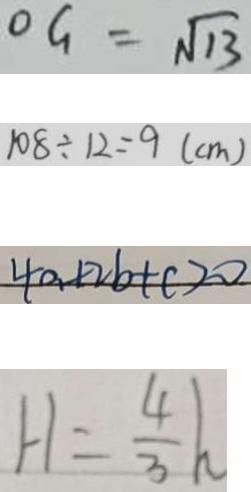<formula> <loc_0><loc_0><loc_500><loc_500>O G = \sqrt { 1 3 } 
 1 0 8 \div 1 2 = 9 ( c m ) 
 4 a + 2 b + c > 0 
 H = \frac { 4 } { 3 } h</formula> 